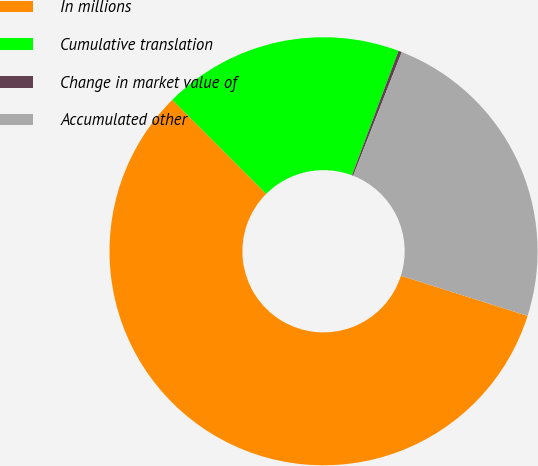Convert chart. <chart><loc_0><loc_0><loc_500><loc_500><pie_chart><fcel>In millions<fcel>Cumulative translation<fcel>Change in market value of<fcel>Accumulated other<nl><fcel>57.63%<fcel>18.19%<fcel>0.26%<fcel>23.92%<nl></chart> 